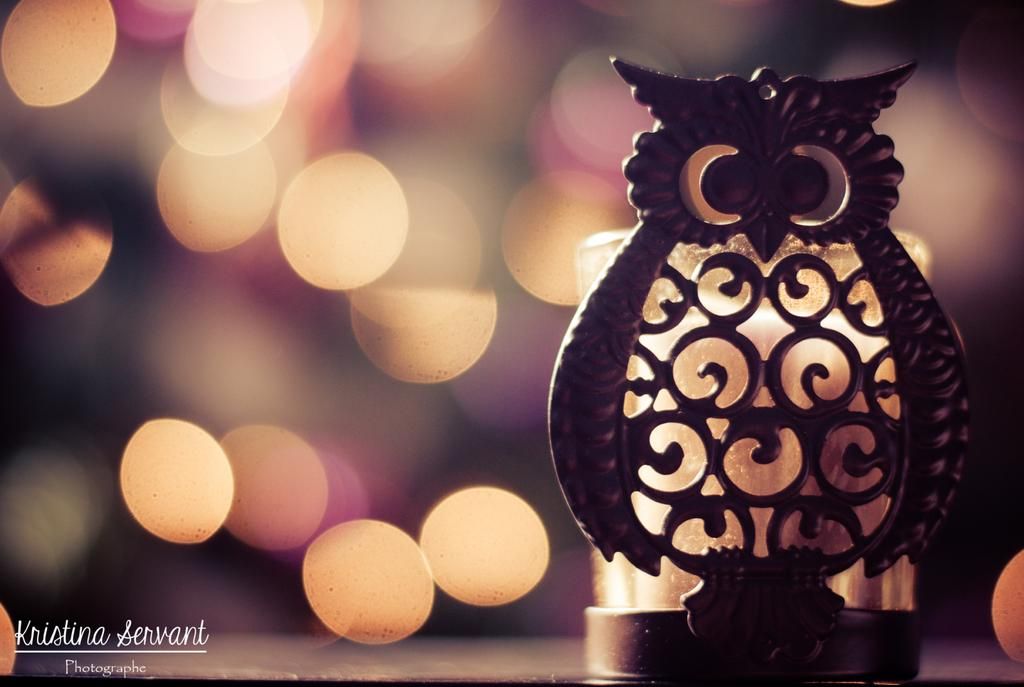What is the main subject of the image? There is an object that resembles an owl in the image. Can you describe the background of the image? There are lights visible in the background of the image. What type of behavior can be observed in the playground in the image? There is no playground present in the image, so no behavior can be observed in a playground. 